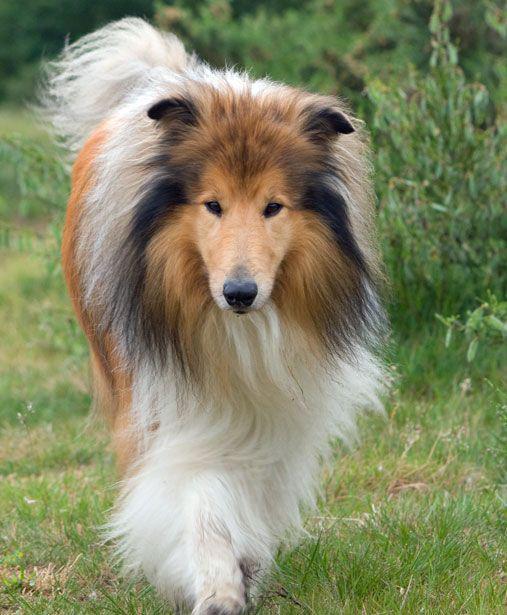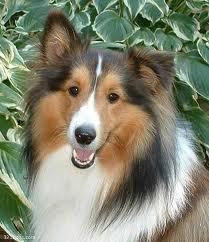The first image is the image on the left, the second image is the image on the right. For the images displayed, is the sentence "The left image contains exactly two dogs." factually correct? Answer yes or no. No. The first image is the image on the left, the second image is the image on the right. Considering the images on both sides, is "Young collies are posed sitting upright side-by-side in one image, and the other image shows one collie reclining with its head upright." valid? Answer yes or no. No. 